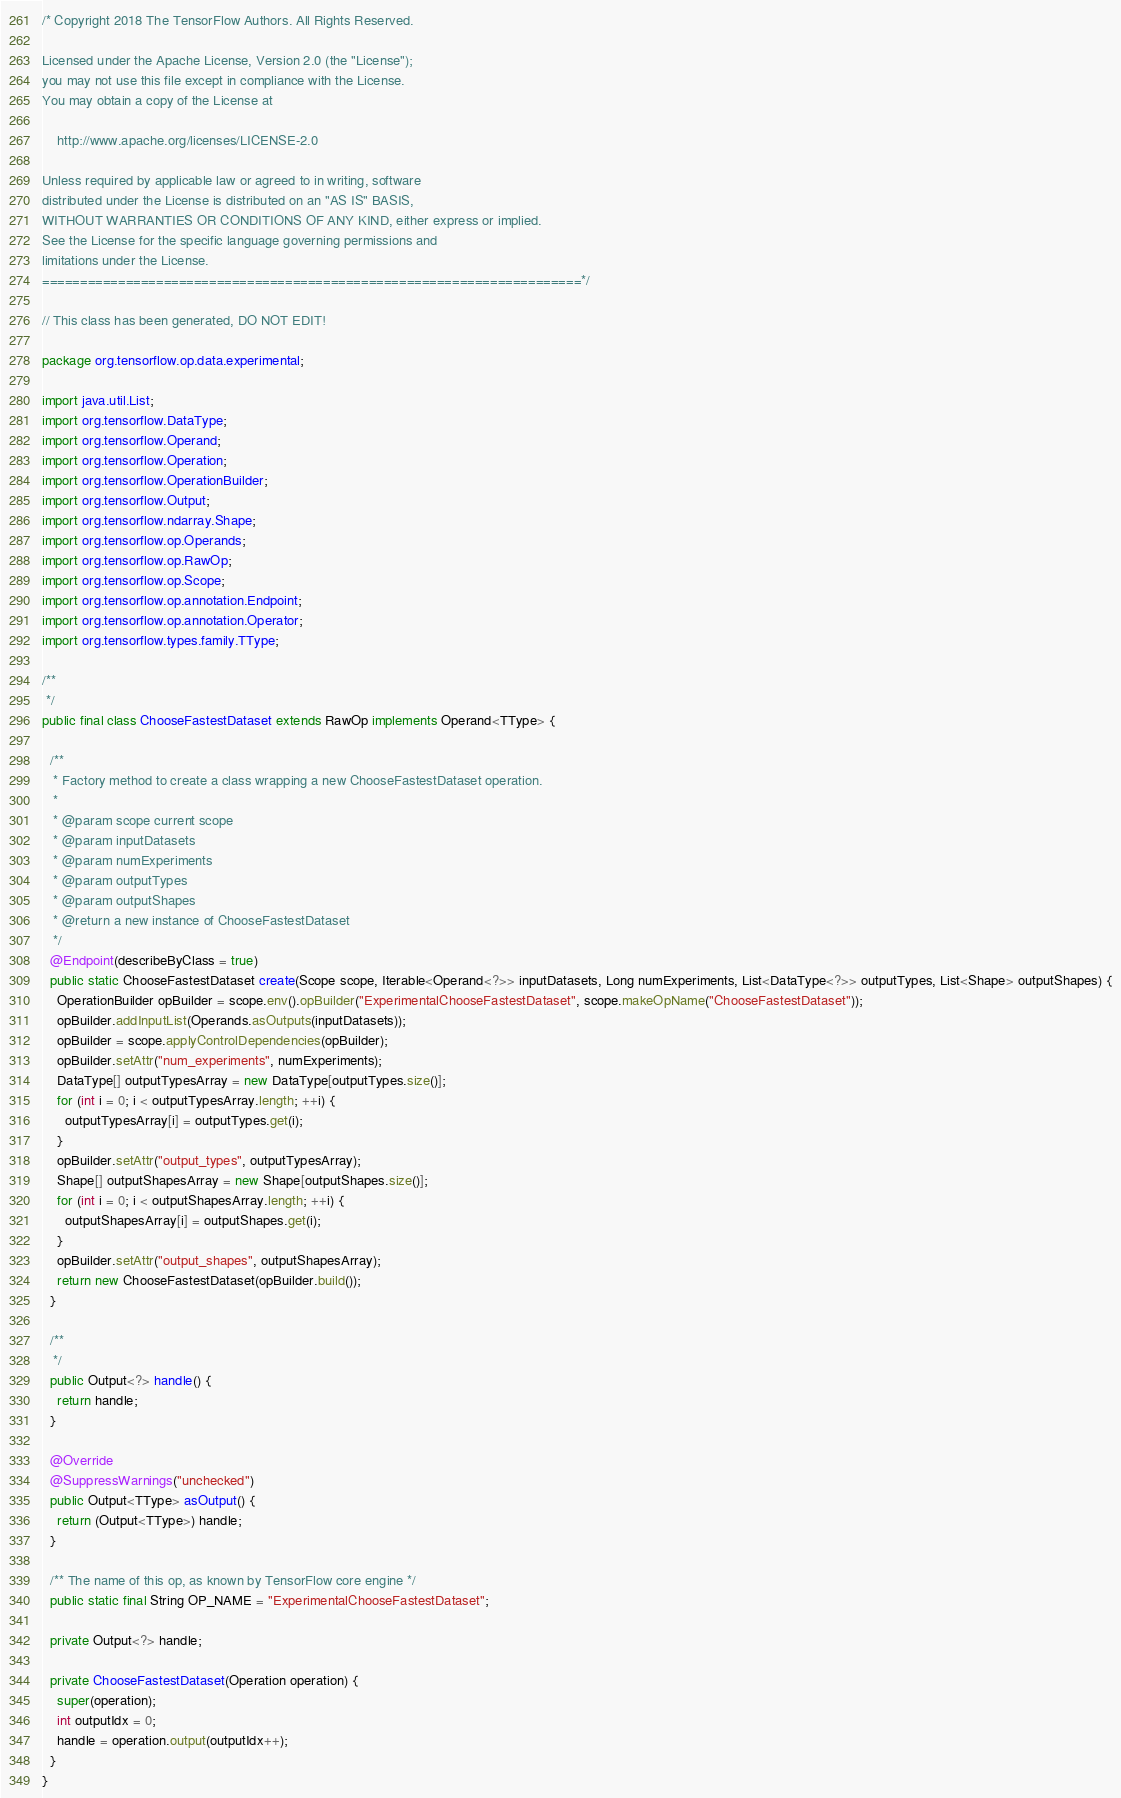<code> <loc_0><loc_0><loc_500><loc_500><_Java_>/* Copyright 2018 The TensorFlow Authors. All Rights Reserved.

Licensed under the Apache License, Version 2.0 (the "License");
you may not use this file except in compliance with the License.
You may obtain a copy of the License at

    http://www.apache.org/licenses/LICENSE-2.0

Unless required by applicable law or agreed to in writing, software
distributed under the License is distributed on an "AS IS" BASIS,
WITHOUT WARRANTIES OR CONDITIONS OF ANY KIND, either express or implied.
See the License for the specific language governing permissions and
limitations under the License.
=======================================================================*/

// This class has been generated, DO NOT EDIT!

package org.tensorflow.op.data.experimental;

import java.util.List;
import org.tensorflow.DataType;
import org.tensorflow.Operand;
import org.tensorflow.Operation;
import org.tensorflow.OperationBuilder;
import org.tensorflow.Output;
import org.tensorflow.ndarray.Shape;
import org.tensorflow.op.Operands;
import org.tensorflow.op.RawOp;
import org.tensorflow.op.Scope;
import org.tensorflow.op.annotation.Endpoint;
import org.tensorflow.op.annotation.Operator;
import org.tensorflow.types.family.TType;

/**
 */
public final class ChooseFastestDataset extends RawOp implements Operand<TType> {
  
  /**
   * Factory method to create a class wrapping a new ChooseFastestDataset operation.
   * 
   * @param scope current scope
   * @param inputDatasets 
   * @param numExperiments 
   * @param outputTypes 
   * @param outputShapes 
   * @return a new instance of ChooseFastestDataset
   */
  @Endpoint(describeByClass = true)
  public static ChooseFastestDataset create(Scope scope, Iterable<Operand<?>> inputDatasets, Long numExperiments, List<DataType<?>> outputTypes, List<Shape> outputShapes) {
    OperationBuilder opBuilder = scope.env().opBuilder("ExperimentalChooseFastestDataset", scope.makeOpName("ChooseFastestDataset"));
    opBuilder.addInputList(Operands.asOutputs(inputDatasets));
    opBuilder = scope.applyControlDependencies(opBuilder);
    opBuilder.setAttr("num_experiments", numExperiments);
    DataType[] outputTypesArray = new DataType[outputTypes.size()];
    for (int i = 0; i < outputTypesArray.length; ++i) {
      outputTypesArray[i] = outputTypes.get(i);
    }
    opBuilder.setAttr("output_types", outputTypesArray);
    Shape[] outputShapesArray = new Shape[outputShapes.size()];
    for (int i = 0; i < outputShapesArray.length; ++i) {
      outputShapesArray[i] = outputShapes.get(i);
    }
    opBuilder.setAttr("output_shapes", outputShapesArray);
    return new ChooseFastestDataset(opBuilder.build());
  }
  
  /**
   */
  public Output<?> handle() {
    return handle;
  }
  
  @Override
  @SuppressWarnings("unchecked")
  public Output<TType> asOutput() {
    return (Output<TType>) handle;
  }
  
  /** The name of this op, as known by TensorFlow core engine */
  public static final String OP_NAME = "ExperimentalChooseFastestDataset";
  
  private Output<?> handle;
  
  private ChooseFastestDataset(Operation operation) {
    super(operation);
    int outputIdx = 0;
    handle = operation.output(outputIdx++);
  }
}
</code> 